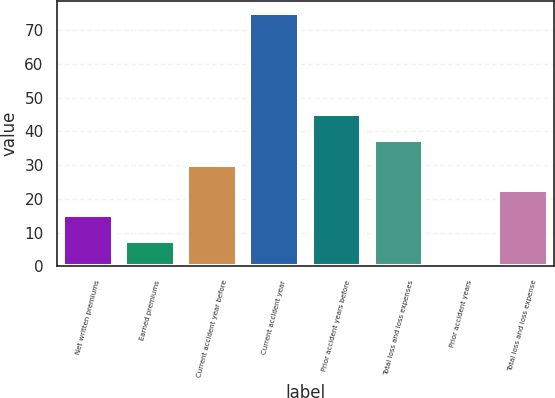Convert chart. <chart><loc_0><loc_0><loc_500><loc_500><bar_chart><fcel>Net written premiums<fcel>Earned premiums<fcel>Current accident year before<fcel>Current accident year<fcel>Prior accident years before<fcel>Total loss and loss expenses<fcel>Prior accident years<fcel>Total loss and loss expense<nl><fcel>15.08<fcel>7.59<fcel>30.06<fcel>75<fcel>45.04<fcel>37.55<fcel>0.1<fcel>22.57<nl></chart> 